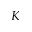<formula> <loc_0><loc_0><loc_500><loc_500>K</formula> 